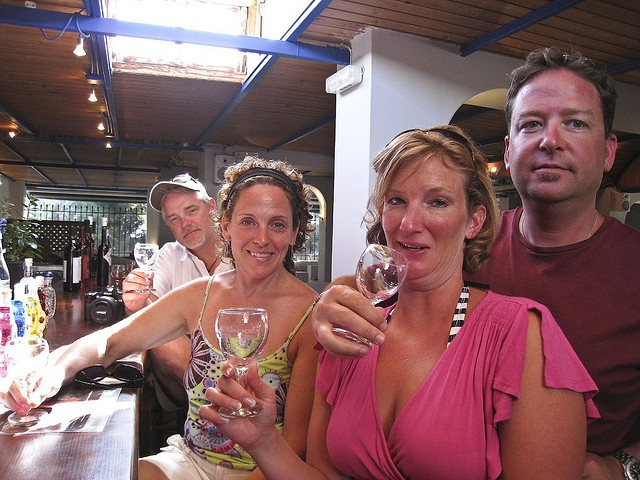Describe the objects in this image and their specific colors. I can see people in black, brown, and maroon tones, people in black, maroon, and brown tones, people in black, brown, white, maroon, and salmon tones, dining table in black, lavender, darkgray, gray, and brown tones, and people in black, brown, lightgray, lightpink, and salmon tones in this image. 